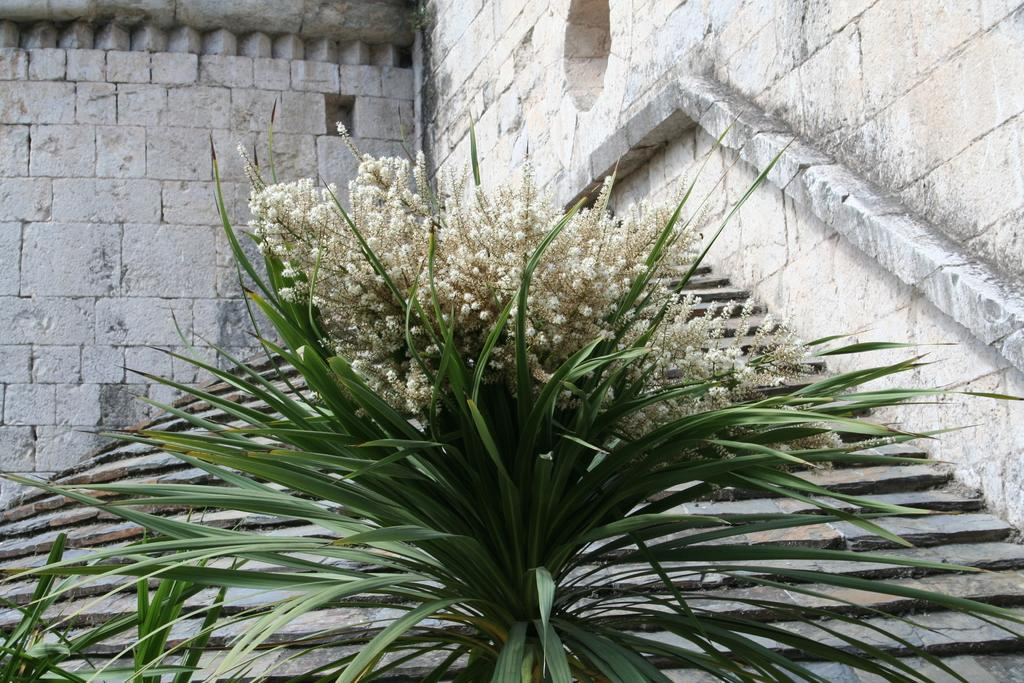What type of plant is present in the image? There are flowers on a plant in the image. What can be seen in the background of the image? There is a building visible in the background of the image. What material is the wall of the building made of? The wall of the building is made up of stone bricks. What decisions is the committee making about the size of the flowers in the image? There is no committee or size-related decisions mentioned in the image. The image only shows flowers on a plant and a building in the background. 